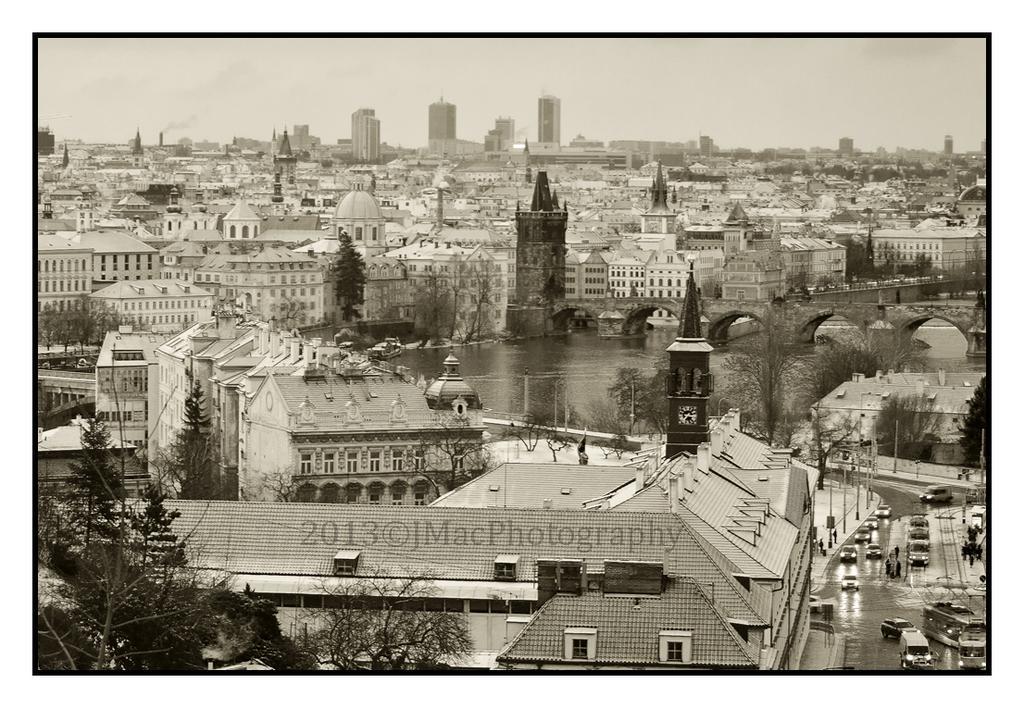Please provide a concise description of this image. In this picture, we can see a few buildings with windows, poles, trees, road, a few vehicles, water, boats, a few people, bridge and the sky, we can see some water mark on the picture. 